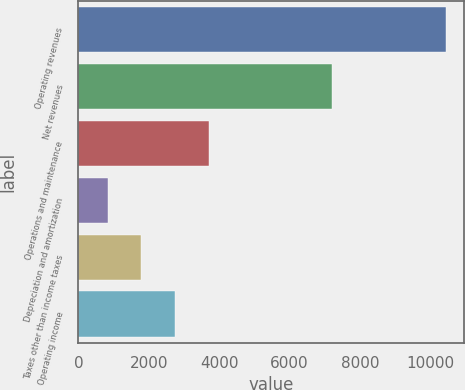Convert chart. <chart><loc_0><loc_0><loc_500><loc_500><bar_chart><fcel>Operating revenues<fcel>Net revenues<fcel>Operations and maintenance<fcel>Depreciation and amortization<fcel>Taxes other than income taxes<fcel>Operating income<nl><fcel>10432<fcel>7189<fcel>3709.9<fcel>829<fcel>1789.3<fcel>2749.6<nl></chart> 